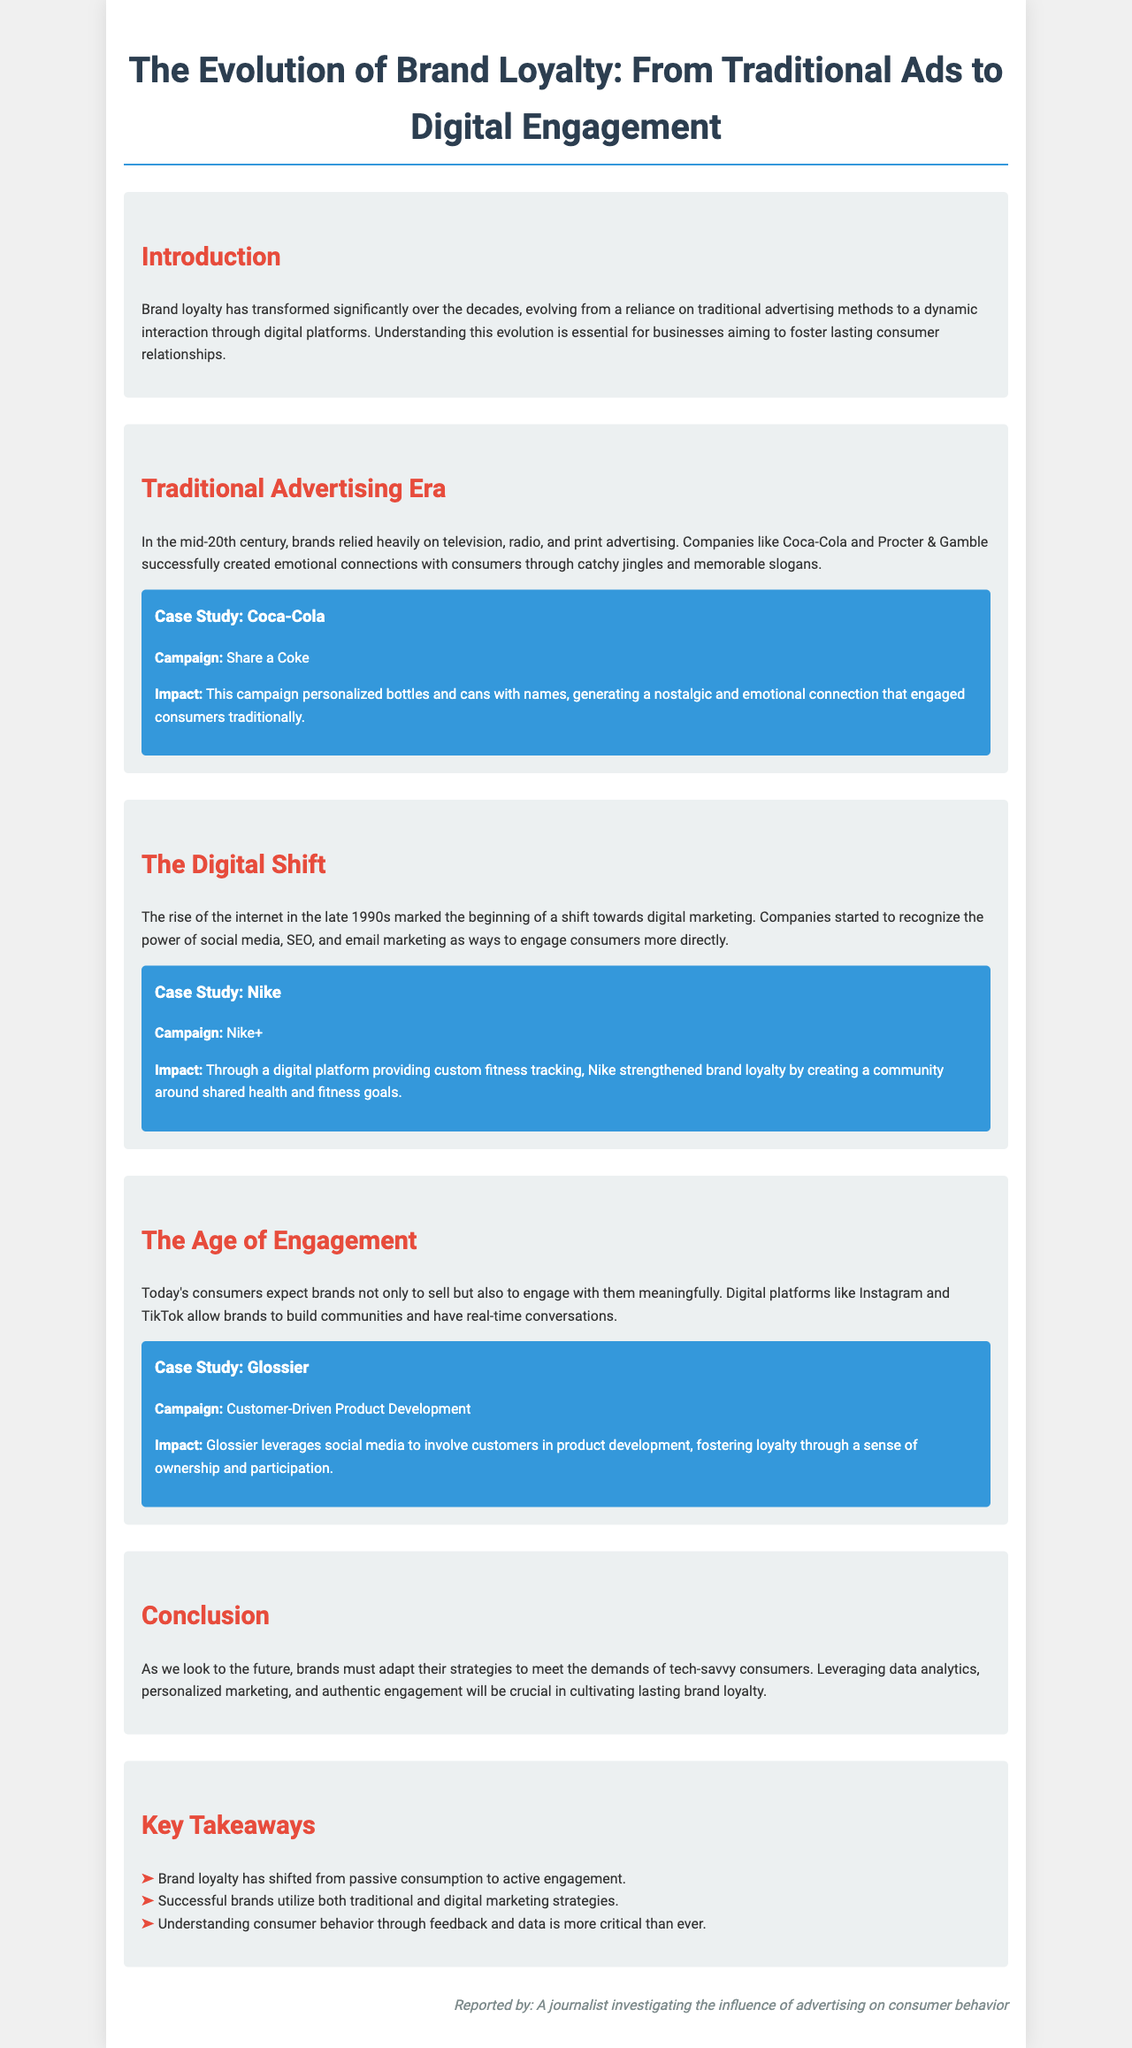What is the title of the document? The title is stated prominently at the top of the brochure.
Answer: The Evolution of Brand Loyalty: From Traditional Ads to Digital Engagement What company is featured in the Coca-Cola case study? This is found under the Traditional Advertising Era section, detailing a specific campaign.
Answer: Coca-Cola What digital campaign did Nike launch? This is mentioned as an example in the Digital Shift section, highlighting their innovation.
Answer: Nike+ Which brand encourages customer-driven product development? The brand is specified within the Age of Engagement section, focusing on a modern approach.
Answer: Glossier What factors are crucial for cultivating brand loyalty in the future? This is summarized in the Conclusion section, outlining key strategies for brands.
Answer: Data analytics, personalized marketing, and authentic engagement What era saw a shift towards digital marketing? This is mentioned in the section discussing the transition from traditional advertising.
Answer: Late 1990s What type of advertising methods were used in the mid-20th century? This is described in the Traditional Advertising Era section, giving context on brand strategies.
Answer: Television, radio, and print advertising How do successful brands utilize marketing strategies today? This is outlined in the Key Takeaways section, summarizing the preferred approach.
Answer: Both traditional and digital marketing strategies 